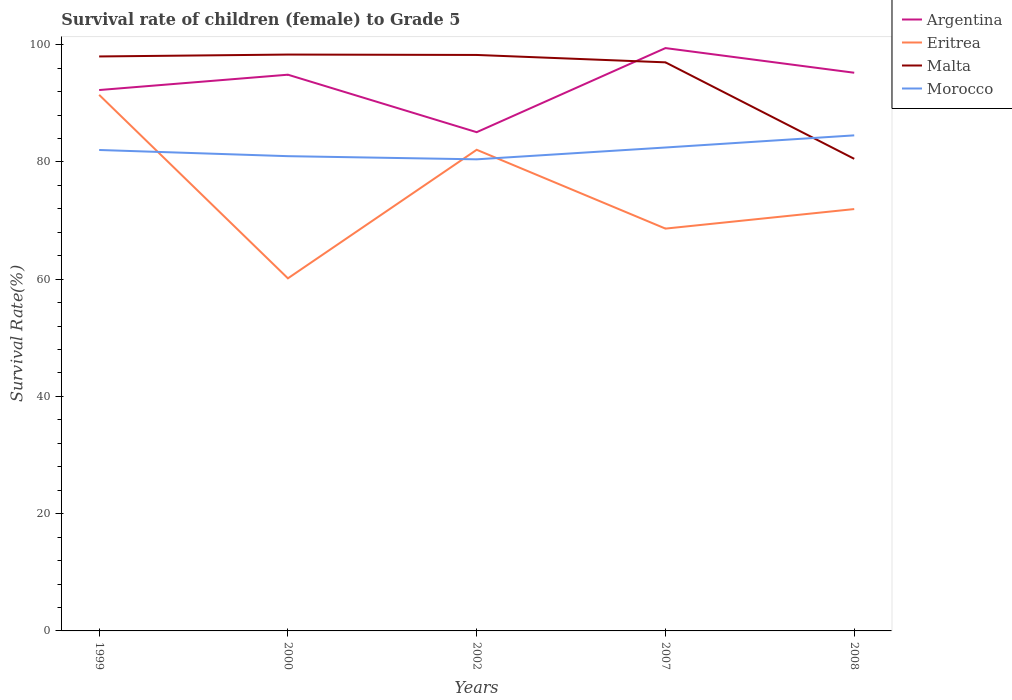How many different coloured lines are there?
Keep it short and to the point. 4. Does the line corresponding to Argentina intersect with the line corresponding to Morocco?
Your response must be concise. No. Across all years, what is the maximum survival rate of female children to grade 5 in Malta?
Keep it short and to the point. 80.54. In which year was the survival rate of female children to grade 5 in Malta maximum?
Keep it short and to the point. 2008. What is the total survival rate of female children to grade 5 in Malta in the graph?
Ensure brevity in your answer.  1.33. What is the difference between the highest and the second highest survival rate of female children to grade 5 in Malta?
Keep it short and to the point. 17.79. What is the difference between the highest and the lowest survival rate of female children to grade 5 in Malta?
Give a very brief answer. 4. Is the survival rate of female children to grade 5 in Malta strictly greater than the survival rate of female children to grade 5 in Eritrea over the years?
Give a very brief answer. No. How many lines are there?
Provide a succinct answer. 4. How many years are there in the graph?
Your answer should be compact. 5. Are the values on the major ticks of Y-axis written in scientific E-notation?
Make the answer very short. No. What is the title of the graph?
Offer a terse response. Survival rate of children (female) to Grade 5. What is the label or title of the Y-axis?
Provide a short and direct response. Survival Rate(%). What is the Survival Rate(%) in Argentina in 1999?
Offer a terse response. 92.27. What is the Survival Rate(%) of Eritrea in 1999?
Your answer should be compact. 91.45. What is the Survival Rate(%) of Malta in 1999?
Provide a short and direct response. 98. What is the Survival Rate(%) in Morocco in 1999?
Offer a very short reply. 82.04. What is the Survival Rate(%) of Argentina in 2000?
Offer a terse response. 94.89. What is the Survival Rate(%) of Eritrea in 2000?
Provide a succinct answer. 60.15. What is the Survival Rate(%) in Malta in 2000?
Provide a short and direct response. 98.32. What is the Survival Rate(%) in Morocco in 2000?
Make the answer very short. 80.99. What is the Survival Rate(%) in Argentina in 2002?
Give a very brief answer. 85.08. What is the Survival Rate(%) of Eritrea in 2002?
Ensure brevity in your answer.  82.08. What is the Survival Rate(%) in Malta in 2002?
Ensure brevity in your answer.  98.26. What is the Survival Rate(%) in Morocco in 2002?
Offer a very short reply. 80.45. What is the Survival Rate(%) of Argentina in 2007?
Give a very brief answer. 99.43. What is the Survival Rate(%) in Eritrea in 2007?
Your response must be concise. 68.63. What is the Survival Rate(%) in Malta in 2007?
Provide a short and direct response. 97. What is the Survival Rate(%) in Morocco in 2007?
Your answer should be compact. 82.47. What is the Survival Rate(%) of Argentina in 2008?
Your answer should be compact. 95.22. What is the Survival Rate(%) in Eritrea in 2008?
Your answer should be compact. 71.96. What is the Survival Rate(%) in Malta in 2008?
Give a very brief answer. 80.54. What is the Survival Rate(%) of Morocco in 2008?
Make the answer very short. 84.54. Across all years, what is the maximum Survival Rate(%) of Argentina?
Ensure brevity in your answer.  99.43. Across all years, what is the maximum Survival Rate(%) in Eritrea?
Offer a very short reply. 91.45. Across all years, what is the maximum Survival Rate(%) in Malta?
Your response must be concise. 98.32. Across all years, what is the maximum Survival Rate(%) of Morocco?
Provide a short and direct response. 84.54. Across all years, what is the minimum Survival Rate(%) of Argentina?
Provide a succinct answer. 85.08. Across all years, what is the minimum Survival Rate(%) of Eritrea?
Ensure brevity in your answer.  60.15. Across all years, what is the minimum Survival Rate(%) of Malta?
Offer a terse response. 80.54. Across all years, what is the minimum Survival Rate(%) of Morocco?
Offer a very short reply. 80.45. What is the total Survival Rate(%) of Argentina in the graph?
Provide a succinct answer. 466.89. What is the total Survival Rate(%) of Eritrea in the graph?
Make the answer very short. 374.28. What is the total Survival Rate(%) in Malta in the graph?
Keep it short and to the point. 472.11. What is the total Survival Rate(%) of Morocco in the graph?
Keep it short and to the point. 410.49. What is the difference between the Survival Rate(%) of Argentina in 1999 and that in 2000?
Keep it short and to the point. -2.62. What is the difference between the Survival Rate(%) in Eritrea in 1999 and that in 2000?
Provide a short and direct response. 31.3. What is the difference between the Survival Rate(%) of Malta in 1999 and that in 2000?
Give a very brief answer. -0.32. What is the difference between the Survival Rate(%) of Morocco in 1999 and that in 2000?
Provide a short and direct response. 1.05. What is the difference between the Survival Rate(%) of Argentina in 1999 and that in 2002?
Your answer should be very brief. 7.19. What is the difference between the Survival Rate(%) in Eritrea in 1999 and that in 2002?
Ensure brevity in your answer.  9.37. What is the difference between the Survival Rate(%) in Malta in 1999 and that in 2002?
Make the answer very short. -0.26. What is the difference between the Survival Rate(%) in Morocco in 1999 and that in 2002?
Your answer should be compact. 1.59. What is the difference between the Survival Rate(%) of Argentina in 1999 and that in 2007?
Your answer should be compact. -7.16. What is the difference between the Survival Rate(%) in Eritrea in 1999 and that in 2007?
Your response must be concise. 22.82. What is the difference between the Survival Rate(%) of Malta in 1999 and that in 2007?
Your answer should be compact. 1. What is the difference between the Survival Rate(%) of Morocco in 1999 and that in 2007?
Provide a succinct answer. -0.42. What is the difference between the Survival Rate(%) of Argentina in 1999 and that in 2008?
Provide a short and direct response. -2.95. What is the difference between the Survival Rate(%) of Eritrea in 1999 and that in 2008?
Your answer should be very brief. 19.49. What is the difference between the Survival Rate(%) in Malta in 1999 and that in 2008?
Offer a terse response. 17.46. What is the difference between the Survival Rate(%) in Morocco in 1999 and that in 2008?
Ensure brevity in your answer.  -2.5. What is the difference between the Survival Rate(%) of Argentina in 2000 and that in 2002?
Provide a succinct answer. 9.81. What is the difference between the Survival Rate(%) in Eritrea in 2000 and that in 2002?
Give a very brief answer. -21.93. What is the difference between the Survival Rate(%) in Malta in 2000 and that in 2002?
Provide a short and direct response. 0.07. What is the difference between the Survival Rate(%) in Morocco in 2000 and that in 2002?
Keep it short and to the point. 0.54. What is the difference between the Survival Rate(%) in Argentina in 2000 and that in 2007?
Provide a short and direct response. -4.54. What is the difference between the Survival Rate(%) of Eritrea in 2000 and that in 2007?
Ensure brevity in your answer.  -8.48. What is the difference between the Survival Rate(%) in Malta in 2000 and that in 2007?
Provide a succinct answer. 1.33. What is the difference between the Survival Rate(%) in Morocco in 2000 and that in 2007?
Your response must be concise. -1.48. What is the difference between the Survival Rate(%) of Argentina in 2000 and that in 2008?
Give a very brief answer. -0.33. What is the difference between the Survival Rate(%) of Eritrea in 2000 and that in 2008?
Your answer should be very brief. -11.81. What is the difference between the Survival Rate(%) in Malta in 2000 and that in 2008?
Your response must be concise. 17.79. What is the difference between the Survival Rate(%) in Morocco in 2000 and that in 2008?
Give a very brief answer. -3.55. What is the difference between the Survival Rate(%) of Argentina in 2002 and that in 2007?
Offer a very short reply. -14.35. What is the difference between the Survival Rate(%) in Eritrea in 2002 and that in 2007?
Offer a very short reply. 13.45. What is the difference between the Survival Rate(%) in Malta in 2002 and that in 2007?
Keep it short and to the point. 1.26. What is the difference between the Survival Rate(%) in Morocco in 2002 and that in 2007?
Your response must be concise. -2.02. What is the difference between the Survival Rate(%) in Argentina in 2002 and that in 2008?
Provide a short and direct response. -10.14. What is the difference between the Survival Rate(%) of Eritrea in 2002 and that in 2008?
Give a very brief answer. 10.12. What is the difference between the Survival Rate(%) of Malta in 2002 and that in 2008?
Your answer should be very brief. 17.72. What is the difference between the Survival Rate(%) of Morocco in 2002 and that in 2008?
Your answer should be very brief. -4.09. What is the difference between the Survival Rate(%) of Argentina in 2007 and that in 2008?
Keep it short and to the point. 4.21. What is the difference between the Survival Rate(%) in Eritrea in 2007 and that in 2008?
Ensure brevity in your answer.  -3.33. What is the difference between the Survival Rate(%) in Malta in 2007 and that in 2008?
Ensure brevity in your answer.  16.46. What is the difference between the Survival Rate(%) of Morocco in 2007 and that in 2008?
Offer a very short reply. -2.07. What is the difference between the Survival Rate(%) of Argentina in 1999 and the Survival Rate(%) of Eritrea in 2000?
Make the answer very short. 32.12. What is the difference between the Survival Rate(%) of Argentina in 1999 and the Survival Rate(%) of Malta in 2000?
Provide a succinct answer. -6.05. What is the difference between the Survival Rate(%) in Argentina in 1999 and the Survival Rate(%) in Morocco in 2000?
Offer a terse response. 11.28. What is the difference between the Survival Rate(%) of Eritrea in 1999 and the Survival Rate(%) of Malta in 2000?
Make the answer very short. -6.87. What is the difference between the Survival Rate(%) in Eritrea in 1999 and the Survival Rate(%) in Morocco in 2000?
Your answer should be very brief. 10.46. What is the difference between the Survival Rate(%) in Malta in 1999 and the Survival Rate(%) in Morocco in 2000?
Your response must be concise. 17.01. What is the difference between the Survival Rate(%) of Argentina in 1999 and the Survival Rate(%) of Eritrea in 2002?
Keep it short and to the point. 10.19. What is the difference between the Survival Rate(%) of Argentina in 1999 and the Survival Rate(%) of Malta in 2002?
Make the answer very short. -5.99. What is the difference between the Survival Rate(%) in Argentina in 1999 and the Survival Rate(%) in Morocco in 2002?
Make the answer very short. 11.82. What is the difference between the Survival Rate(%) of Eritrea in 1999 and the Survival Rate(%) of Malta in 2002?
Make the answer very short. -6.81. What is the difference between the Survival Rate(%) in Eritrea in 1999 and the Survival Rate(%) in Morocco in 2002?
Make the answer very short. 11. What is the difference between the Survival Rate(%) of Malta in 1999 and the Survival Rate(%) of Morocco in 2002?
Make the answer very short. 17.55. What is the difference between the Survival Rate(%) in Argentina in 1999 and the Survival Rate(%) in Eritrea in 2007?
Keep it short and to the point. 23.64. What is the difference between the Survival Rate(%) of Argentina in 1999 and the Survival Rate(%) of Malta in 2007?
Your answer should be very brief. -4.73. What is the difference between the Survival Rate(%) of Argentina in 1999 and the Survival Rate(%) of Morocco in 2007?
Keep it short and to the point. 9.8. What is the difference between the Survival Rate(%) of Eritrea in 1999 and the Survival Rate(%) of Malta in 2007?
Offer a very short reply. -5.55. What is the difference between the Survival Rate(%) in Eritrea in 1999 and the Survival Rate(%) in Morocco in 2007?
Make the answer very short. 8.98. What is the difference between the Survival Rate(%) of Malta in 1999 and the Survival Rate(%) of Morocco in 2007?
Your response must be concise. 15.53. What is the difference between the Survival Rate(%) in Argentina in 1999 and the Survival Rate(%) in Eritrea in 2008?
Offer a terse response. 20.31. What is the difference between the Survival Rate(%) in Argentina in 1999 and the Survival Rate(%) in Malta in 2008?
Your answer should be very brief. 11.73. What is the difference between the Survival Rate(%) of Argentina in 1999 and the Survival Rate(%) of Morocco in 2008?
Keep it short and to the point. 7.73. What is the difference between the Survival Rate(%) in Eritrea in 1999 and the Survival Rate(%) in Malta in 2008?
Offer a very short reply. 10.91. What is the difference between the Survival Rate(%) in Eritrea in 1999 and the Survival Rate(%) in Morocco in 2008?
Offer a very short reply. 6.91. What is the difference between the Survival Rate(%) of Malta in 1999 and the Survival Rate(%) of Morocco in 2008?
Offer a very short reply. 13.46. What is the difference between the Survival Rate(%) of Argentina in 2000 and the Survival Rate(%) of Eritrea in 2002?
Your answer should be very brief. 12.81. What is the difference between the Survival Rate(%) in Argentina in 2000 and the Survival Rate(%) in Malta in 2002?
Offer a terse response. -3.37. What is the difference between the Survival Rate(%) in Argentina in 2000 and the Survival Rate(%) in Morocco in 2002?
Provide a succinct answer. 14.44. What is the difference between the Survival Rate(%) of Eritrea in 2000 and the Survival Rate(%) of Malta in 2002?
Make the answer very short. -38.11. What is the difference between the Survival Rate(%) in Eritrea in 2000 and the Survival Rate(%) in Morocco in 2002?
Offer a terse response. -20.3. What is the difference between the Survival Rate(%) of Malta in 2000 and the Survival Rate(%) of Morocco in 2002?
Ensure brevity in your answer.  17.87. What is the difference between the Survival Rate(%) of Argentina in 2000 and the Survival Rate(%) of Eritrea in 2007?
Provide a short and direct response. 26.25. What is the difference between the Survival Rate(%) in Argentina in 2000 and the Survival Rate(%) in Malta in 2007?
Your answer should be compact. -2.11. What is the difference between the Survival Rate(%) of Argentina in 2000 and the Survival Rate(%) of Morocco in 2007?
Keep it short and to the point. 12.42. What is the difference between the Survival Rate(%) of Eritrea in 2000 and the Survival Rate(%) of Malta in 2007?
Ensure brevity in your answer.  -36.85. What is the difference between the Survival Rate(%) of Eritrea in 2000 and the Survival Rate(%) of Morocco in 2007?
Ensure brevity in your answer.  -22.32. What is the difference between the Survival Rate(%) in Malta in 2000 and the Survival Rate(%) in Morocco in 2007?
Give a very brief answer. 15.86. What is the difference between the Survival Rate(%) in Argentina in 2000 and the Survival Rate(%) in Eritrea in 2008?
Offer a very short reply. 22.92. What is the difference between the Survival Rate(%) of Argentina in 2000 and the Survival Rate(%) of Malta in 2008?
Provide a succinct answer. 14.35. What is the difference between the Survival Rate(%) of Argentina in 2000 and the Survival Rate(%) of Morocco in 2008?
Your response must be concise. 10.35. What is the difference between the Survival Rate(%) of Eritrea in 2000 and the Survival Rate(%) of Malta in 2008?
Offer a very short reply. -20.39. What is the difference between the Survival Rate(%) in Eritrea in 2000 and the Survival Rate(%) in Morocco in 2008?
Offer a very short reply. -24.39. What is the difference between the Survival Rate(%) of Malta in 2000 and the Survival Rate(%) of Morocco in 2008?
Provide a short and direct response. 13.78. What is the difference between the Survival Rate(%) of Argentina in 2002 and the Survival Rate(%) of Eritrea in 2007?
Provide a short and direct response. 16.45. What is the difference between the Survival Rate(%) in Argentina in 2002 and the Survival Rate(%) in Malta in 2007?
Offer a very short reply. -11.91. What is the difference between the Survival Rate(%) in Argentina in 2002 and the Survival Rate(%) in Morocco in 2007?
Make the answer very short. 2.61. What is the difference between the Survival Rate(%) of Eritrea in 2002 and the Survival Rate(%) of Malta in 2007?
Offer a very short reply. -14.92. What is the difference between the Survival Rate(%) in Eritrea in 2002 and the Survival Rate(%) in Morocco in 2007?
Make the answer very short. -0.39. What is the difference between the Survival Rate(%) of Malta in 2002 and the Survival Rate(%) of Morocco in 2007?
Provide a succinct answer. 15.79. What is the difference between the Survival Rate(%) of Argentina in 2002 and the Survival Rate(%) of Eritrea in 2008?
Give a very brief answer. 13.12. What is the difference between the Survival Rate(%) of Argentina in 2002 and the Survival Rate(%) of Malta in 2008?
Offer a very short reply. 4.54. What is the difference between the Survival Rate(%) of Argentina in 2002 and the Survival Rate(%) of Morocco in 2008?
Keep it short and to the point. 0.54. What is the difference between the Survival Rate(%) in Eritrea in 2002 and the Survival Rate(%) in Malta in 2008?
Offer a terse response. 1.54. What is the difference between the Survival Rate(%) in Eritrea in 2002 and the Survival Rate(%) in Morocco in 2008?
Offer a very short reply. -2.46. What is the difference between the Survival Rate(%) in Malta in 2002 and the Survival Rate(%) in Morocco in 2008?
Your answer should be compact. 13.72. What is the difference between the Survival Rate(%) in Argentina in 2007 and the Survival Rate(%) in Eritrea in 2008?
Provide a succinct answer. 27.46. What is the difference between the Survival Rate(%) in Argentina in 2007 and the Survival Rate(%) in Malta in 2008?
Provide a short and direct response. 18.89. What is the difference between the Survival Rate(%) in Argentina in 2007 and the Survival Rate(%) in Morocco in 2008?
Your answer should be very brief. 14.89. What is the difference between the Survival Rate(%) of Eritrea in 2007 and the Survival Rate(%) of Malta in 2008?
Your response must be concise. -11.9. What is the difference between the Survival Rate(%) in Eritrea in 2007 and the Survival Rate(%) in Morocco in 2008?
Keep it short and to the point. -15.91. What is the difference between the Survival Rate(%) of Malta in 2007 and the Survival Rate(%) of Morocco in 2008?
Offer a very short reply. 12.46. What is the average Survival Rate(%) in Argentina per year?
Your response must be concise. 93.38. What is the average Survival Rate(%) in Eritrea per year?
Provide a short and direct response. 74.86. What is the average Survival Rate(%) in Malta per year?
Your answer should be very brief. 94.42. What is the average Survival Rate(%) of Morocco per year?
Your answer should be very brief. 82.1. In the year 1999, what is the difference between the Survival Rate(%) of Argentina and Survival Rate(%) of Eritrea?
Give a very brief answer. 0.82. In the year 1999, what is the difference between the Survival Rate(%) in Argentina and Survival Rate(%) in Malta?
Make the answer very short. -5.73. In the year 1999, what is the difference between the Survival Rate(%) in Argentina and Survival Rate(%) in Morocco?
Your answer should be very brief. 10.23. In the year 1999, what is the difference between the Survival Rate(%) of Eritrea and Survival Rate(%) of Malta?
Offer a terse response. -6.55. In the year 1999, what is the difference between the Survival Rate(%) of Eritrea and Survival Rate(%) of Morocco?
Offer a terse response. 9.41. In the year 1999, what is the difference between the Survival Rate(%) of Malta and Survival Rate(%) of Morocco?
Keep it short and to the point. 15.96. In the year 2000, what is the difference between the Survival Rate(%) of Argentina and Survival Rate(%) of Eritrea?
Your answer should be very brief. 34.74. In the year 2000, what is the difference between the Survival Rate(%) in Argentina and Survival Rate(%) in Malta?
Offer a terse response. -3.44. In the year 2000, what is the difference between the Survival Rate(%) in Argentina and Survival Rate(%) in Morocco?
Keep it short and to the point. 13.9. In the year 2000, what is the difference between the Survival Rate(%) in Eritrea and Survival Rate(%) in Malta?
Your answer should be very brief. -38.17. In the year 2000, what is the difference between the Survival Rate(%) of Eritrea and Survival Rate(%) of Morocco?
Your response must be concise. -20.84. In the year 2000, what is the difference between the Survival Rate(%) in Malta and Survival Rate(%) in Morocco?
Your answer should be very brief. 17.33. In the year 2002, what is the difference between the Survival Rate(%) in Argentina and Survival Rate(%) in Eritrea?
Keep it short and to the point. 3. In the year 2002, what is the difference between the Survival Rate(%) in Argentina and Survival Rate(%) in Malta?
Your response must be concise. -13.18. In the year 2002, what is the difference between the Survival Rate(%) in Argentina and Survival Rate(%) in Morocco?
Your answer should be very brief. 4.63. In the year 2002, what is the difference between the Survival Rate(%) in Eritrea and Survival Rate(%) in Malta?
Keep it short and to the point. -16.18. In the year 2002, what is the difference between the Survival Rate(%) in Eritrea and Survival Rate(%) in Morocco?
Offer a very short reply. 1.63. In the year 2002, what is the difference between the Survival Rate(%) in Malta and Survival Rate(%) in Morocco?
Your response must be concise. 17.8. In the year 2007, what is the difference between the Survival Rate(%) in Argentina and Survival Rate(%) in Eritrea?
Provide a short and direct response. 30.79. In the year 2007, what is the difference between the Survival Rate(%) in Argentina and Survival Rate(%) in Malta?
Your answer should be compact. 2.43. In the year 2007, what is the difference between the Survival Rate(%) in Argentina and Survival Rate(%) in Morocco?
Provide a succinct answer. 16.96. In the year 2007, what is the difference between the Survival Rate(%) in Eritrea and Survival Rate(%) in Malta?
Provide a succinct answer. -28.36. In the year 2007, what is the difference between the Survival Rate(%) in Eritrea and Survival Rate(%) in Morocco?
Your response must be concise. -13.83. In the year 2007, what is the difference between the Survival Rate(%) in Malta and Survival Rate(%) in Morocco?
Offer a terse response. 14.53. In the year 2008, what is the difference between the Survival Rate(%) of Argentina and Survival Rate(%) of Eritrea?
Give a very brief answer. 23.26. In the year 2008, what is the difference between the Survival Rate(%) of Argentina and Survival Rate(%) of Malta?
Keep it short and to the point. 14.68. In the year 2008, what is the difference between the Survival Rate(%) of Argentina and Survival Rate(%) of Morocco?
Provide a succinct answer. 10.68. In the year 2008, what is the difference between the Survival Rate(%) in Eritrea and Survival Rate(%) in Malta?
Your response must be concise. -8.57. In the year 2008, what is the difference between the Survival Rate(%) in Eritrea and Survival Rate(%) in Morocco?
Your answer should be compact. -12.57. In the year 2008, what is the difference between the Survival Rate(%) in Malta and Survival Rate(%) in Morocco?
Make the answer very short. -4. What is the ratio of the Survival Rate(%) in Argentina in 1999 to that in 2000?
Your answer should be compact. 0.97. What is the ratio of the Survival Rate(%) in Eritrea in 1999 to that in 2000?
Give a very brief answer. 1.52. What is the ratio of the Survival Rate(%) of Malta in 1999 to that in 2000?
Your answer should be compact. 1. What is the ratio of the Survival Rate(%) in Morocco in 1999 to that in 2000?
Ensure brevity in your answer.  1.01. What is the ratio of the Survival Rate(%) in Argentina in 1999 to that in 2002?
Provide a short and direct response. 1.08. What is the ratio of the Survival Rate(%) in Eritrea in 1999 to that in 2002?
Offer a terse response. 1.11. What is the ratio of the Survival Rate(%) in Malta in 1999 to that in 2002?
Ensure brevity in your answer.  1. What is the ratio of the Survival Rate(%) of Morocco in 1999 to that in 2002?
Give a very brief answer. 1.02. What is the ratio of the Survival Rate(%) of Argentina in 1999 to that in 2007?
Offer a terse response. 0.93. What is the ratio of the Survival Rate(%) of Eritrea in 1999 to that in 2007?
Give a very brief answer. 1.33. What is the ratio of the Survival Rate(%) of Malta in 1999 to that in 2007?
Your answer should be very brief. 1.01. What is the ratio of the Survival Rate(%) in Morocco in 1999 to that in 2007?
Provide a short and direct response. 0.99. What is the ratio of the Survival Rate(%) in Eritrea in 1999 to that in 2008?
Your answer should be very brief. 1.27. What is the ratio of the Survival Rate(%) of Malta in 1999 to that in 2008?
Keep it short and to the point. 1.22. What is the ratio of the Survival Rate(%) of Morocco in 1999 to that in 2008?
Ensure brevity in your answer.  0.97. What is the ratio of the Survival Rate(%) in Argentina in 2000 to that in 2002?
Make the answer very short. 1.12. What is the ratio of the Survival Rate(%) in Eritrea in 2000 to that in 2002?
Provide a short and direct response. 0.73. What is the ratio of the Survival Rate(%) in Malta in 2000 to that in 2002?
Give a very brief answer. 1. What is the ratio of the Survival Rate(%) of Argentina in 2000 to that in 2007?
Your response must be concise. 0.95. What is the ratio of the Survival Rate(%) of Eritrea in 2000 to that in 2007?
Offer a terse response. 0.88. What is the ratio of the Survival Rate(%) in Malta in 2000 to that in 2007?
Make the answer very short. 1.01. What is the ratio of the Survival Rate(%) in Morocco in 2000 to that in 2007?
Ensure brevity in your answer.  0.98. What is the ratio of the Survival Rate(%) of Eritrea in 2000 to that in 2008?
Your answer should be very brief. 0.84. What is the ratio of the Survival Rate(%) of Malta in 2000 to that in 2008?
Offer a very short reply. 1.22. What is the ratio of the Survival Rate(%) in Morocco in 2000 to that in 2008?
Offer a terse response. 0.96. What is the ratio of the Survival Rate(%) of Argentina in 2002 to that in 2007?
Provide a succinct answer. 0.86. What is the ratio of the Survival Rate(%) of Eritrea in 2002 to that in 2007?
Give a very brief answer. 1.2. What is the ratio of the Survival Rate(%) in Morocco in 2002 to that in 2007?
Offer a terse response. 0.98. What is the ratio of the Survival Rate(%) in Argentina in 2002 to that in 2008?
Offer a very short reply. 0.89. What is the ratio of the Survival Rate(%) of Eritrea in 2002 to that in 2008?
Your answer should be very brief. 1.14. What is the ratio of the Survival Rate(%) of Malta in 2002 to that in 2008?
Your response must be concise. 1.22. What is the ratio of the Survival Rate(%) in Morocco in 2002 to that in 2008?
Your answer should be very brief. 0.95. What is the ratio of the Survival Rate(%) in Argentina in 2007 to that in 2008?
Provide a short and direct response. 1.04. What is the ratio of the Survival Rate(%) in Eritrea in 2007 to that in 2008?
Your response must be concise. 0.95. What is the ratio of the Survival Rate(%) in Malta in 2007 to that in 2008?
Ensure brevity in your answer.  1.2. What is the ratio of the Survival Rate(%) of Morocco in 2007 to that in 2008?
Offer a very short reply. 0.98. What is the difference between the highest and the second highest Survival Rate(%) of Argentina?
Your response must be concise. 4.21. What is the difference between the highest and the second highest Survival Rate(%) of Eritrea?
Keep it short and to the point. 9.37. What is the difference between the highest and the second highest Survival Rate(%) in Malta?
Provide a short and direct response. 0.07. What is the difference between the highest and the second highest Survival Rate(%) in Morocco?
Ensure brevity in your answer.  2.07. What is the difference between the highest and the lowest Survival Rate(%) of Argentina?
Your answer should be compact. 14.35. What is the difference between the highest and the lowest Survival Rate(%) of Eritrea?
Keep it short and to the point. 31.3. What is the difference between the highest and the lowest Survival Rate(%) in Malta?
Your answer should be very brief. 17.79. What is the difference between the highest and the lowest Survival Rate(%) of Morocco?
Your response must be concise. 4.09. 